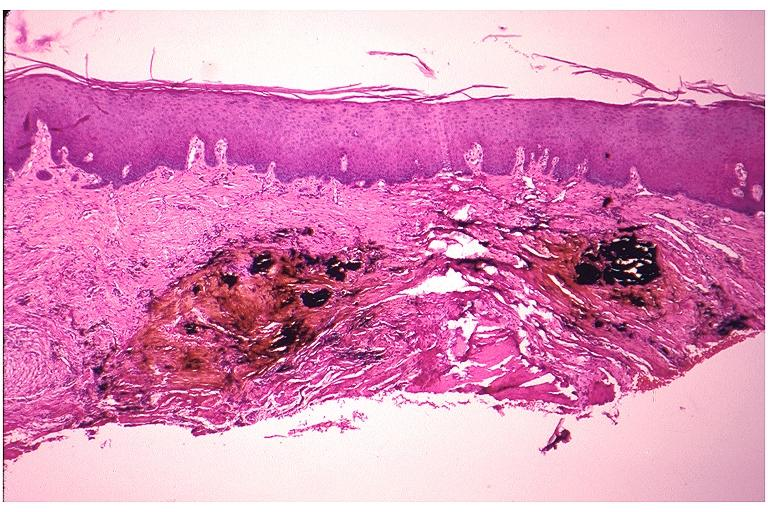does this image show amalgam tattoo?
Answer the question using a single word or phrase. Yes 